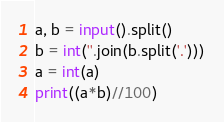<code> <loc_0><loc_0><loc_500><loc_500><_Python_>a, b = input().split()
b = int(''.join(b.split('.')))
a = int(a)
print((a*b)//100)</code> 